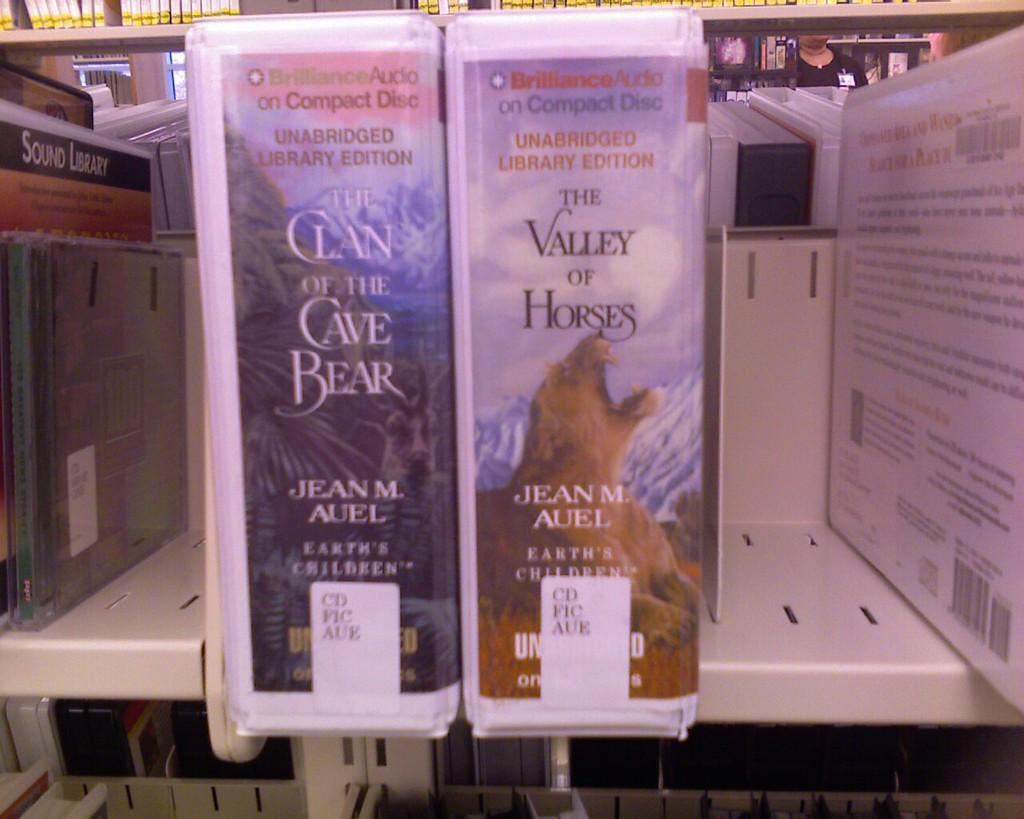<image>
Summarize the visual content of the image. Two Jean Auel books on CD are side by side on a shelf. 